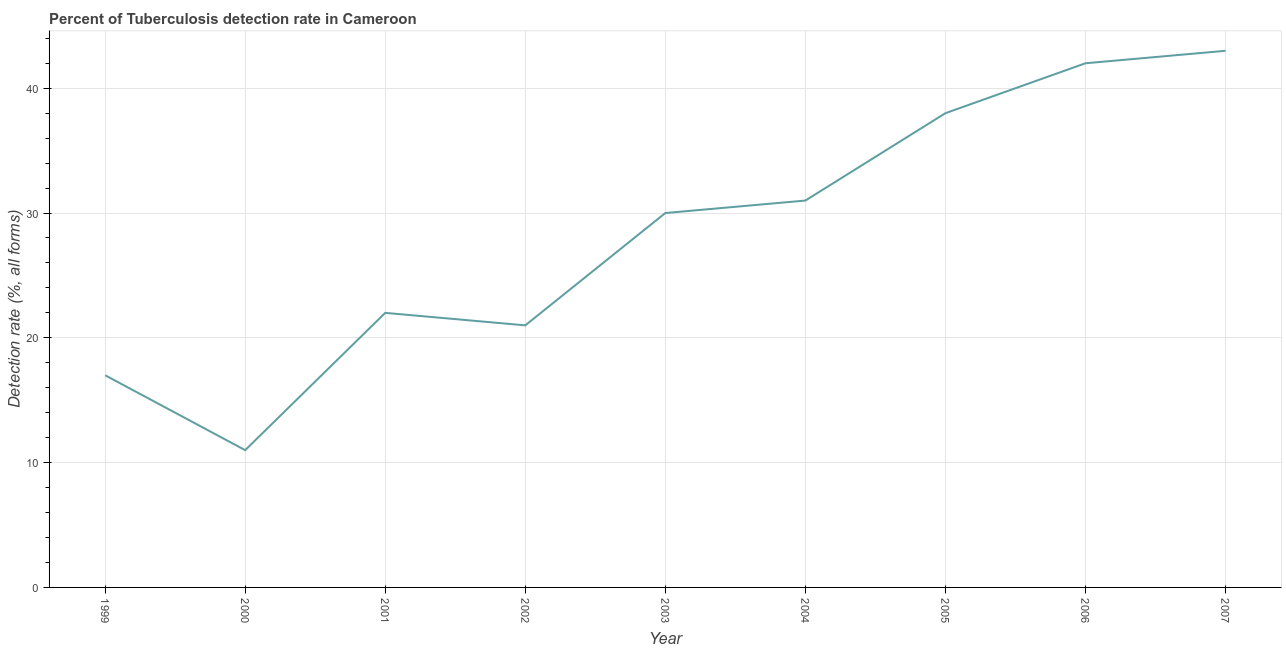What is the detection rate of tuberculosis in 2000?
Your response must be concise. 11. Across all years, what is the maximum detection rate of tuberculosis?
Offer a very short reply. 43. Across all years, what is the minimum detection rate of tuberculosis?
Offer a very short reply. 11. In which year was the detection rate of tuberculosis minimum?
Provide a short and direct response. 2000. What is the sum of the detection rate of tuberculosis?
Make the answer very short. 255. What is the difference between the detection rate of tuberculosis in 2002 and 2006?
Offer a very short reply. -21. What is the average detection rate of tuberculosis per year?
Your response must be concise. 28.33. What is the median detection rate of tuberculosis?
Keep it short and to the point. 30. Do a majority of the years between 2001 and 2006 (inclusive) have detection rate of tuberculosis greater than 4 %?
Your answer should be very brief. Yes. What is the ratio of the detection rate of tuberculosis in 2001 to that in 2005?
Provide a succinct answer. 0.58. Is the difference between the detection rate of tuberculosis in 1999 and 2003 greater than the difference between any two years?
Give a very brief answer. No. What is the difference between the highest and the second highest detection rate of tuberculosis?
Give a very brief answer. 1. Is the sum of the detection rate of tuberculosis in 2000 and 2006 greater than the maximum detection rate of tuberculosis across all years?
Offer a terse response. Yes. In how many years, is the detection rate of tuberculosis greater than the average detection rate of tuberculosis taken over all years?
Your answer should be very brief. 5. How many lines are there?
Your answer should be compact. 1. What is the difference between two consecutive major ticks on the Y-axis?
Provide a succinct answer. 10. Are the values on the major ticks of Y-axis written in scientific E-notation?
Ensure brevity in your answer.  No. Does the graph contain grids?
Offer a terse response. Yes. What is the title of the graph?
Keep it short and to the point. Percent of Tuberculosis detection rate in Cameroon. What is the label or title of the X-axis?
Your answer should be very brief. Year. What is the label or title of the Y-axis?
Provide a short and direct response. Detection rate (%, all forms). What is the Detection rate (%, all forms) in 2001?
Make the answer very short. 22. What is the Detection rate (%, all forms) of 2002?
Provide a succinct answer. 21. What is the Detection rate (%, all forms) of 2003?
Your response must be concise. 30. What is the Detection rate (%, all forms) in 2005?
Give a very brief answer. 38. What is the Detection rate (%, all forms) of 2006?
Ensure brevity in your answer.  42. What is the difference between the Detection rate (%, all forms) in 1999 and 2001?
Your response must be concise. -5. What is the difference between the Detection rate (%, all forms) in 1999 and 2002?
Offer a terse response. -4. What is the difference between the Detection rate (%, all forms) in 1999 and 2003?
Offer a very short reply. -13. What is the difference between the Detection rate (%, all forms) in 1999 and 2007?
Provide a succinct answer. -26. What is the difference between the Detection rate (%, all forms) in 2000 and 2001?
Your answer should be compact. -11. What is the difference between the Detection rate (%, all forms) in 2000 and 2002?
Provide a short and direct response. -10. What is the difference between the Detection rate (%, all forms) in 2000 and 2005?
Make the answer very short. -27. What is the difference between the Detection rate (%, all forms) in 2000 and 2006?
Provide a succinct answer. -31. What is the difference between the Detection rate (%, all forms) in 2000 and 2007?
Your answer should be very brief. -32. What is the difference between the Detection rate (%, all forms) in 2001 and 2003?
Your response must be concise. -8. What is the difference between the Detection rate (%, all forms) in 2002 and 2003?
Your answer should be compact. -9. What is the difference between the Detection rate (%, all forms) in 2002 and 2005?
Make the answer very short. -17. What is the difference between the Detection rate (%, all forms) in 2002 and 2007?
Ensure brevity in your answer.  -22. What is the difference between the Detection rate (%, all forms) in 2003 and 2004?
Offer a terse response. -1. What is the difference between the Detection rate (%, all forms) in 2003 and 2006?
Make the answer very short. -12. What is the difference between the Detection rate (%, all forms) in 2003 and 2007?
Provide a succinct answer. -13. What is the difference between the Detection rate (%, all forms) in 2004 and 2006?
Offer a terse response. -11. What is the difference between the Detection rate (%, all forms) in 2004 and 2007?
Give a very brief answer. -12. What is the difference between the Detection rate (%, all forms) in 2005 and 2006?
Your response must be concise. -4. What is the difference between the Detection rate (%, all forms) in 2005 and 2007?
Your answer should be compact. -5. What is the ratio of the Detection rate (%, all forms) in 1999 to that in 2000?
Offer a very short reply. 1.54. What is the ratio of the Detection rate (%, all forms) in 1999 to that in 2001?
Your answer should be very brief. 0.77. What is the ratio of the Detection rate (%, all forms) in 1999 to that in 2002?
Keep it short and to the point. 0.81. What is the ratio of the Detection rate (%, all forms) in 1999 to that in 2003?
Ensure brevity in your answer.  0.57. What is the ratio of the Detection rate (%, all forms) in 1999 to that in 2004?
Your response must be concise. 0.55. What is the ratio of the Detection rate (%, all forms) in 1999 to that in 2005?
Provide a succinct answer. 0.45. What is the ratio of the Detection rate (%, all forms) in 1999 to that in 2006?
Give a very brief answer. 0.41. What is the ratio of the Detection rate (%, all forms) in 1999 to that in 2007?
Offer a very short reply. 0.4. What is the ratio of the Detection rate (%, all forms) in 2000 to that in 2002?
Provide a short and direct response. 0.52. What is the ratio of the Detection rate (%, all forms) in 2000 to that in 2003?
Your response must be concise. 0.37. What is the ratio of the Detection rate (%, all forms) in 2000 to that in 2004?
Your answer should be compact. 0.35. What is the ratio of the Detection rate (%, all forms) in 2000 to that in 2005?
Your response must be concise. 0.29. What is the ratio of the Detection rate (%, all forms) in 2000 to that in 2006?
Your answer should be compact. 0.26. What is the ratio of the Detection rate (%, all forms) in 2000 to that in 2007?
Offer a very short reply. 0.26. What is the ratio of the Detection rate (%, all forms) in 2001 to that in 2002?
Your response must be concise. 1.05. What is the ratio of the Detection rate (%, all forms) in 2001 to that in 2003?
Provide a short and direct response. 0.73. What is the ratio of the Detection rate (%, all forms) in 2001 to that in 2004?
Ensure brevity in your answer.  0.71. What is the ratio of the Detection rate (%, all forms) in 2001 to that in 2005?
Ensure brevity in your answer.  0.58. What is the ratio of the Detection rate (%, all forms) in 2001 to that in 2006?
Provide a succinct answer. 0.52. What is the ratio of the Detection rate (%, all forms) in 2001 to that in 2007?
Provide a succinct answer. 0.51. What is the ratio of the Detection rate (%, all forms) in 2002 to that in 2004?
Provide a succinct answer. 0.68. What is the ratio of the Detection rate (%, all forms) in 2002 to that in 2005?
Your answer should be compact. 0.55. What is the ratio of the Detection rate (%, all forms) in 2002 to that in 2006?
Offer a terse response. 0.5. What is the ratio of the Detection rate (%, all forms) in 2002 to that in 2007?
Keep it short and to the point. 0.49. What is the ratio of the Detection rate (%, all forms) in 2003 to that in 2004?
Ensure brevity in your answer.  0.97. What is the ratio of the Detection rate (%, all forms) in 2003 to that in 2005?
Give a very brief answer. 0.79. What is the ratio of the Detection rate (%, all forms) in 2003 to that in 2006?
Your answer should be very brief. 0.71. What is the ratio of the Detection rate (%, all forms) in 2003 to that in 2007?
Keep it short and to the point. 0.7. What is the ratio of the Detection rate (%, all forms) in 2004 to that in 2005?
Give a very brief answer. 0.82. What is the ratio of the Detection rate (%, all forms) in 2004 to that in 2006?
Offer a terse response. 0.74. What is the ratio of the Detection rate (%, all forms) in 2004 to that in 2007?
Make the answer very short. 0.72. What is the ratio of the Detection rate (%, all forms) in 2005 to that in 2006?
Your response must be concise. 0.91. What is the ratio of the Detection rate (%, all forms) in 2005 to that in 2007?
Offer a terse response. 0.88. 